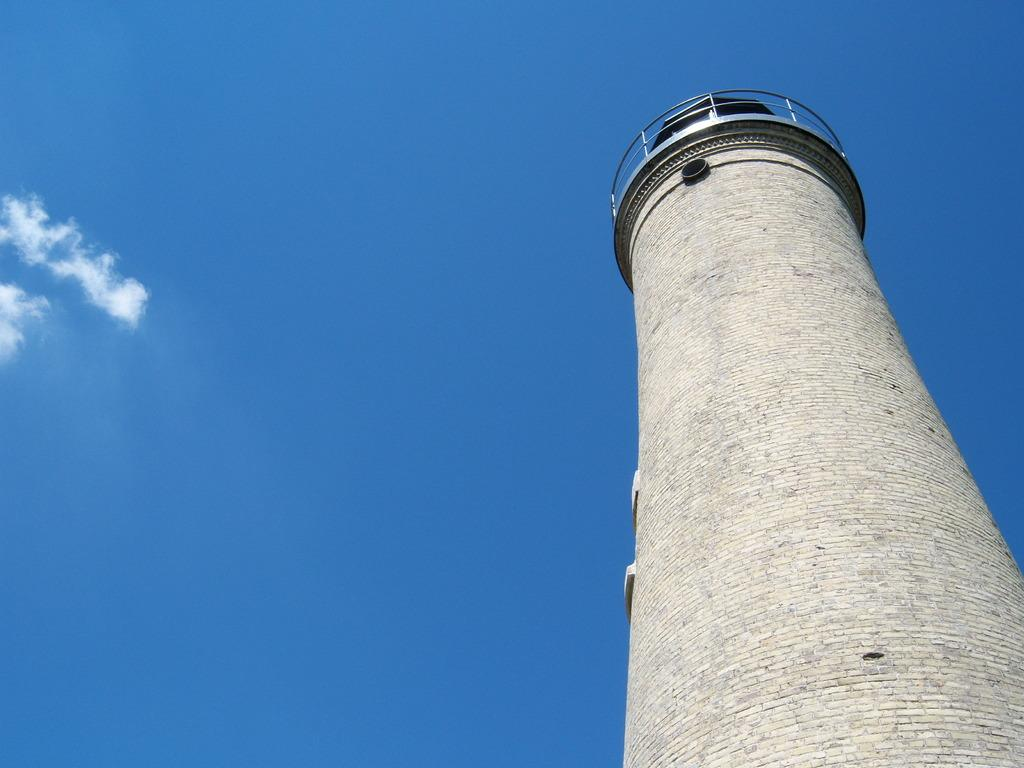What structure is located on the right side of the image? There is a tower on the right side of the image. What is visible in the background of the image? The sky is visible in the background of the image. How many steps can be seen leading up to the tower in the image? There is no information about steps leading up to the tower in the image. 